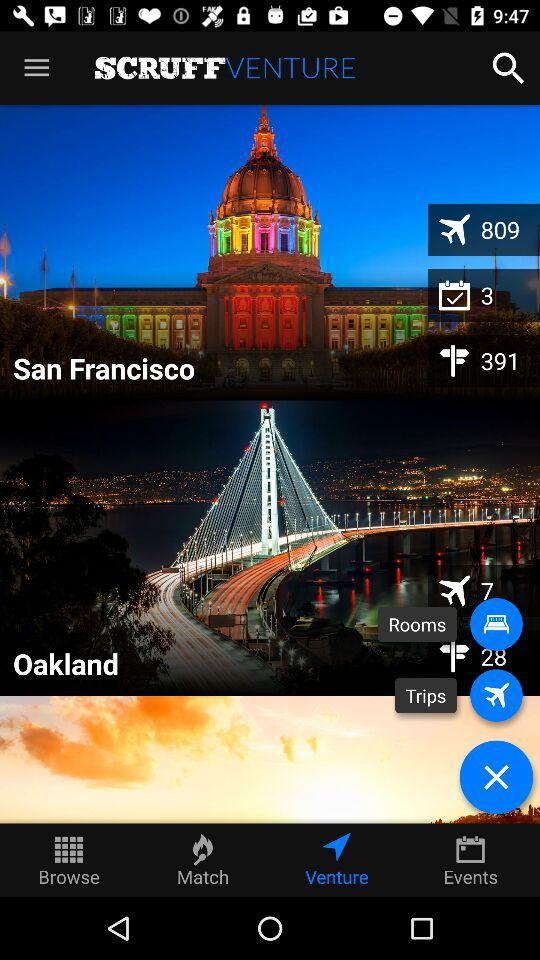Which are the names of the two places given on the screen? The names of the two places given on the screen are San Francisco and Oakland. 